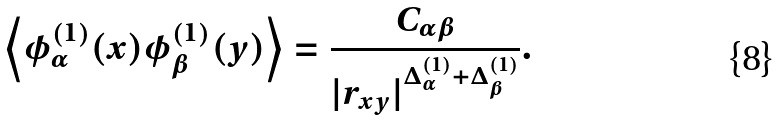<formula> <loc_0><loc_0><loc_500><loc_500>\left \langle \phi _ { \alpha } ^ { ( 1 ) } ( x ) \phi _ { \beta } ^ { ( 1 ) } ( y ) \right \rangle = \frac { C _ { \alpha \beta } } { | r _ { x y } | ^ { \Delta ^ { ( 1 ) } _ { \alpha } + \Delta ^ { ( 1 ) } _ { \beta } } } .</formula> 